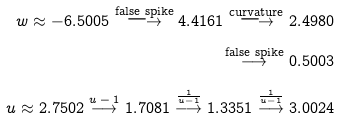Convert formula to latex. <formula><loc_0><loc_0><loc_500><loc_500>w \approx - 6 . 5 0 0 5 \stackrel { \text {false spike} } { \longrightarrow } 4 . 4 1 6 1 \stackrel { \text {curvature} } { \longrightarrow } 2 . 4 9 8 0 \\ \stackrel { \text {false spike} } { \longrightarrow } 0 . 5 0 0 3 \\ u \approx 2 . 7 5 0 2 \stackrel { \text {$u-1$} } { \longrightarrow } 1 . 7 0 8 1 \stackrel { \text {$\frac{1}{u-1}$} } { \longrightarrow } 1 . 3 3 5 1 \stackrel { \text {$\frac{1}{u-1}$} } { \longrightarrow } 3 . 0 0 2 4</formula> 